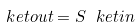Convert formula to latex. <formula><loc_0><loc_0><loc_500><loc_500>\ k e t { o u t } = S \ k e t { i n }</formula> 